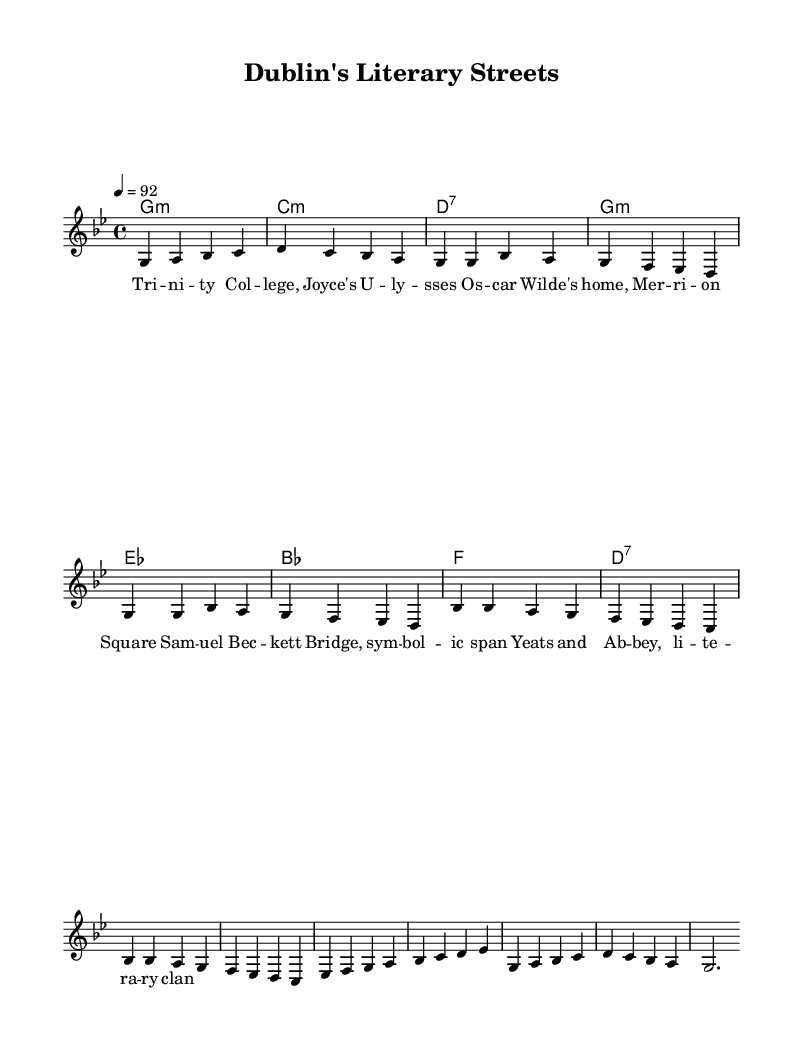What is the key signature of this music? The key signature is G minor, which has two flats (B flat and E flat). We can determine the key signature by looking at the initial part of the score under the note that represents the key.
Answer: G minor What is the time signature indicated in the music? The time signature is 4/4, which is recognizable at the beginning of the score where the time signature is indicated. It means there are four beats in each measure and the quarter note gets one beat.
Answer: 4/4 What is the tempo marking given for this piece? The tempo marking is 92, which signifies that the quarter note gets a beat of 92 beats per minute. It is typically found near the beginning of the score in the tempo indication section.
Answer: 92 How many measures does the chorus section have? The chorus section comprises 4 measures, as we can count the musical bars represented in this part of the score. Each line in the score corresponds to a set of measures, and the chorus clearly outlining four bars confirms this.
Answer: 4 What is the last note in the melody of the outro? The last note in the melody of the outro is A, which we can see at the end of the melody section following the sequence of notes leading to the final measure. It concludes the melody with a specific pitch indicated as A.
Answer: A Which Irish literary figure is referenced in the lyrics? The lyrics reference James Joyce, whose work 'Ulysses' is famously associated with Dublin. This can be identified by looking for his name in the lyrics beneath the music notation.
Answer: Joyce 